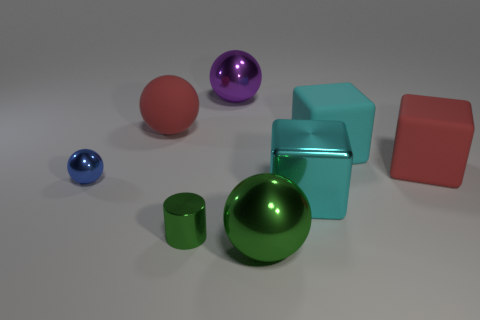How many things are either tiny gray rubber cylinders or big objects that are to the right of the green shiny cylinder?
Offer a very short reply. 5. The sphere that is right of the tiny green metal cylinder and behind the cyan metal object is what color?
Your answer should be very brief. Purple. Is the size of the cyan shiny cube the same as the red rubber cube?
Your answer should be compact. Yes. What color is the large ball in front of the small metal ball?
Offer a terse response. Green. Are there any rubber blocks of the same color as the small metallic cylinder?
Offer a terse response. No. What color is the rubber sphere that is the same size as the purple metallic sphere?
Ensure brevity in your answer.  Red. Is the shape of the blue metallic object the same as the small green object?
Ensure brevity in your answer.  No. There is a large cyan cube in front of the blue thing; what is it made of?
Provide a short and direct response. Metal. What color is the tiny metal cylinder?
Offer a very short reply. Green. Do the red object on the left side of the cyan matte thing and the cyan matte thing to the right of the large metallic block have the same size?
Keep it short and to the point. Yes. 